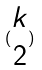Convert formula to latex. <formula><loc_0><loc_0><loc_500><loc_500>( \begin{matrix} k \\ 2 \end{matrix} )</formula> 